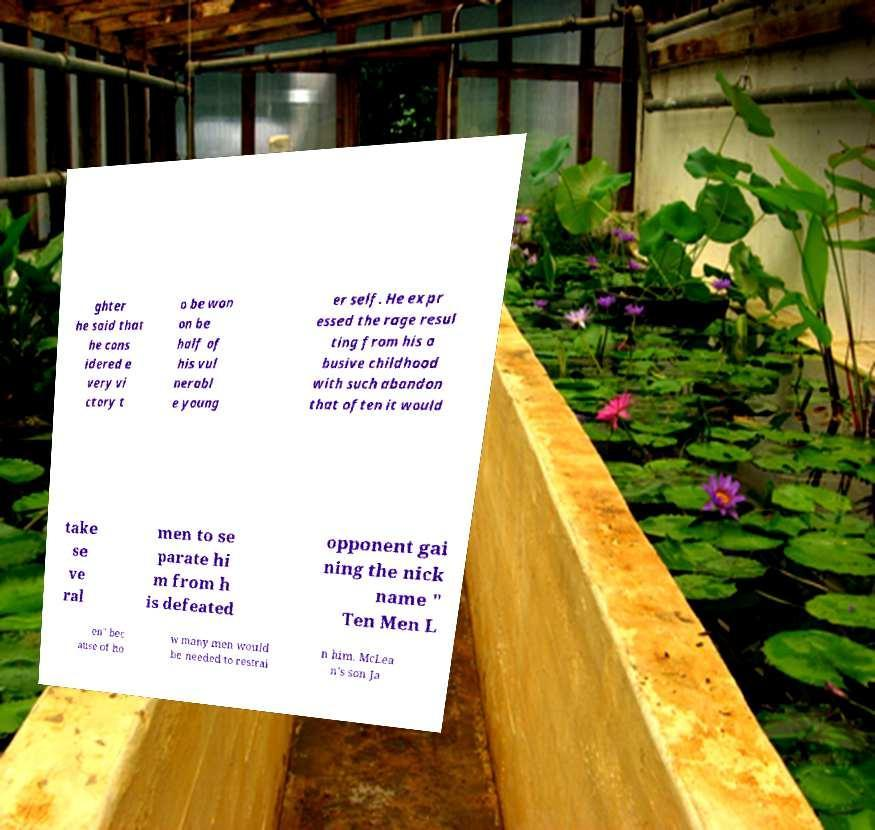There's text embedded in this image that I need extracted. Can you transcribe it verbatim? ghter he said that he cons idered e very vi ctory t o be won on be half of his vul nerabl e young er self. He expr essed the rage resul ting from his a busive childhood with such abandon that often it would take se ve ral men to se parate hi m from h is defeated opponent gai ning the nick name " Ten Men L en" bec ause of ho w many men would be needed to restrai n him. McLea n's son Ja 